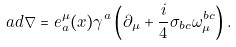Convert formula to latex. <formula><loc_0><loc_0><loc_500><loc_500>\sl a d { \nabla } = e ^ { \mu } _ { a } ( x ) \gamma ^ { a } \left ( \partial _ { \mu } + \frac { i } { 4 } \sigma _ { b c } \omega ^ { b c } _ { \mu } \right ) .</formula> 